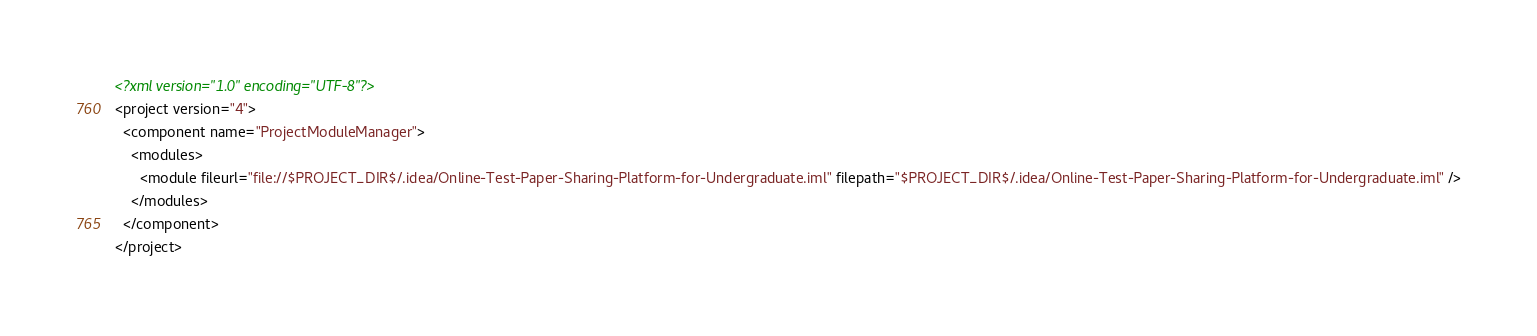Convert code to text. <code><loc_0><loc_0><loc_500><loc_500><_XML_><?xml version="1.0" encoding="UTF-8"?>
<project version="4">
  <component name="ProjectModuleManager">
    <modules>
      <module fileurl="file://$PROJECT_DIR$/.idea/Online-Test-Paper-Sharing-Platform-for-Undergraduate.iml" filepath="$PROJECT_DIR$/.idea/Online-Test-Paper-Sharing-Platform-for-Undergraduate.iml" />
    </modules>
  </component>
</project></code> 